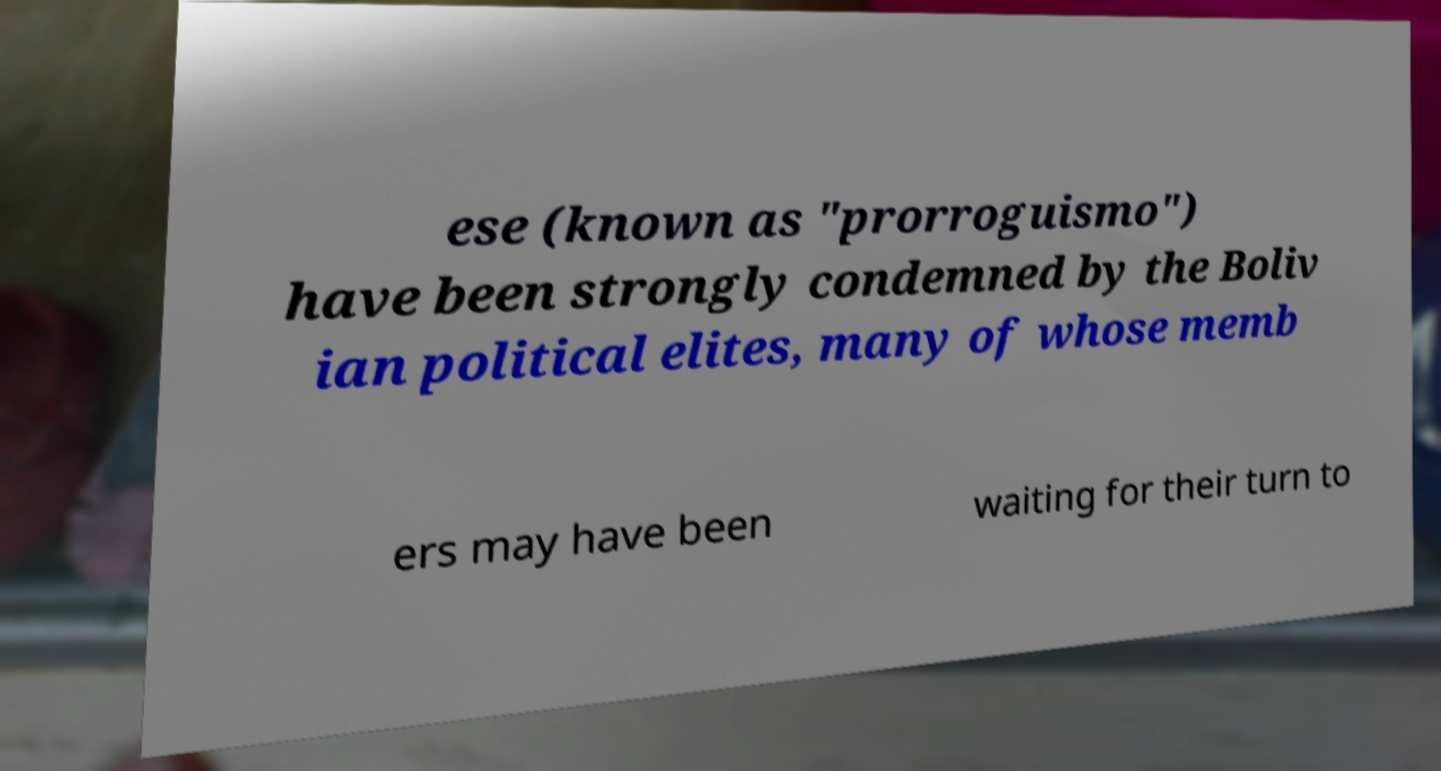What messages or text are displayed in this image? I need them in a readable, typed format. ese (known as "prorroguismo") have been strongly condemned by the Boliv ian political elites, many of whose memb ers may have been waiting for their turn to 